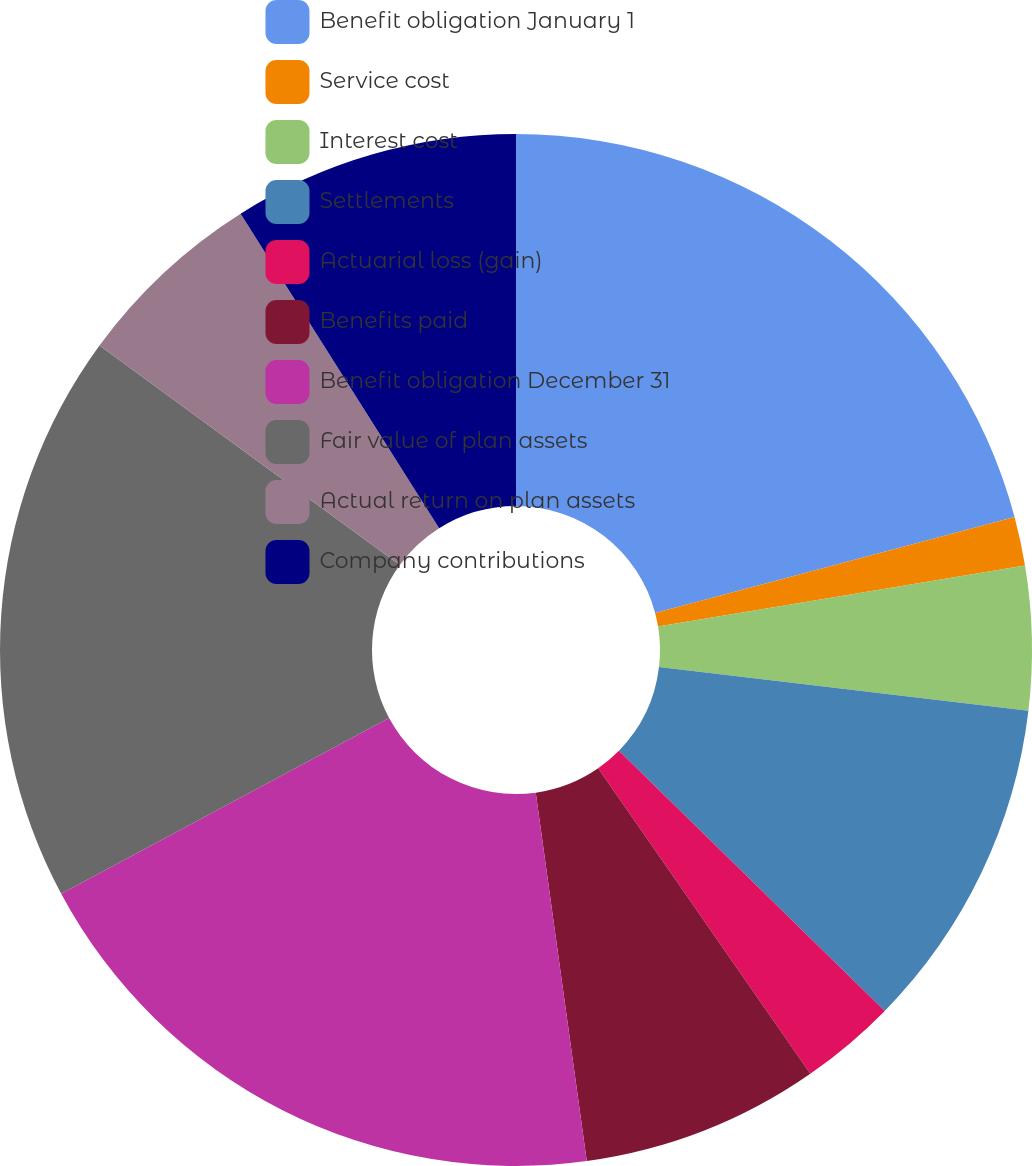Convert chart. <chart><loc_0><loc_0><loc_500><loc_500><pie_chart><fcel>Benefit obligation January 1<fcel>Service cost<fcel>Interest cost<fcel>Settlements<fcel>Actuarial loss (gain)<fcel>Benefits paid<fcel>Benefit obligation December 31<fcel>Fair value of plan assets<fcel>Actual return on plan assets<fcel>Company contributions<nl><fcel>20.85%<fcel>1.53%<fcel>4.5%<fcel>10.45%<fcel>3.01%<fcel>7.47%<fcel>19.36%<fcel>17.88%<fcel>5.99%<fcel>8.96%<nl></chart> 